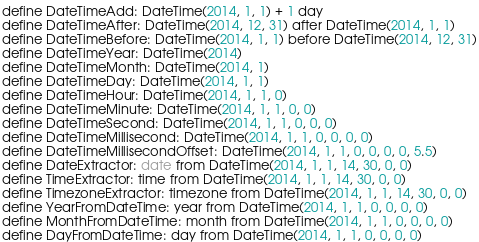<code> <loc_0><loc_0><loc_500><loc_500><_SQL_>define DateTimeAdd: DateTime(2014, 1, 1) + 1 day
define DateTimeAfter: DateTime(2014, 12, 31) after DateTime(2014, 1, 1)
define DateTimeBefore: DateTime(2014, 1, 1) before DateTime(2014, 12, 31)
define DateTimeYear: DateTime(2014)
define DateTimeMonth: DateTime(2014, 1)
define DateTimeDay: DateTime(2014, 1, 1)
define DateTimeHour: DateTime(2014, 1, 1, 0)
define DateTimeMinute: DateTime(2014, 1, 1, 0, 0)
define DateTimeSecond: DateTime(2014, 1, 1, 0, 0, 0)
define DateTimeMillisecond: DateTime(2014, 1, 1, 0, 0, 0, 0)
define DateTimeMillisecondOffset: DateTime(2014, 1, 1, 0, 0, 0, 0, 5.5)
define DateExtractor: date from DateTime(2014, 1, 1, 14, 30, 0, 0)
define TimeExtractor: time from DateTime(2014, 1, 1, 14, 30, 0, 0)
define TimezoneExtractor: timezone from DateTime(2014, 1, 1, 14, 30, 0, 0)
define YearFromDateTime: year from DateTime(2014, 1, 1, 0, 0, 0, 0)
define MonthFromDateTime: month from DateTime(2014, 1, 1, 0, 0, 0, 0)
define DayFromDateTime: day from DateTime(2014, 1, 1, 0, 0, 0, 0)</code> 